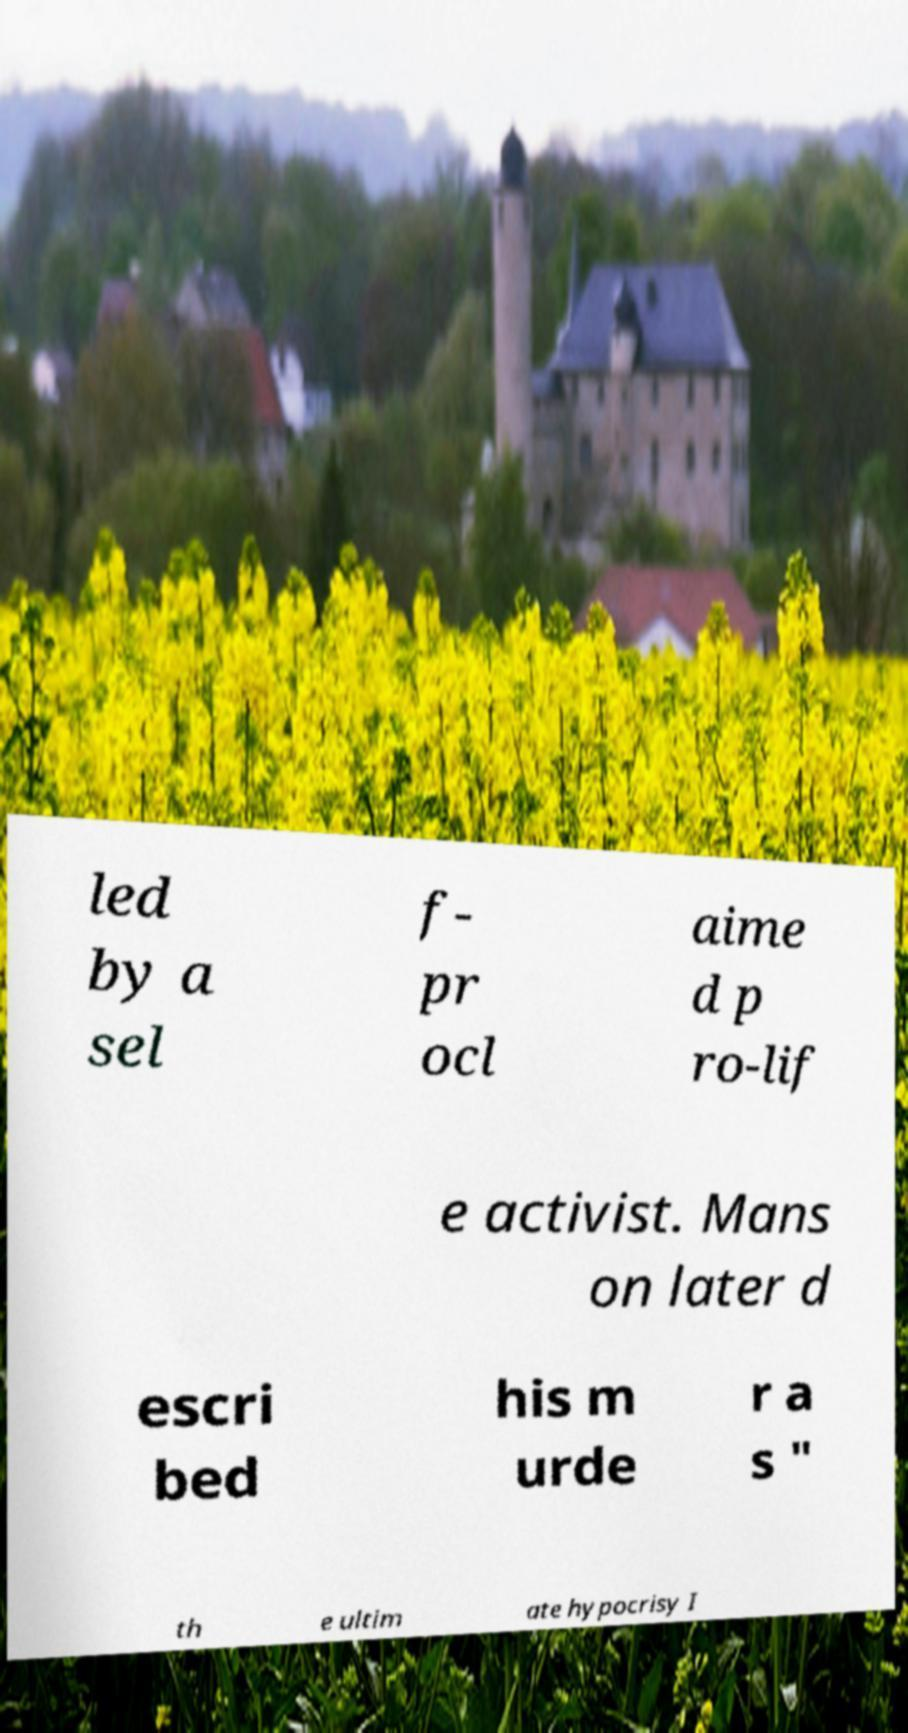What messages or text are displayed in this image? I need them in a readable, typed format. led by a sel f- pr ocl aime d p ro-lif e activist. Mans on later d escri bed his m urde r a s " th e ultim ate hypocrisy I 